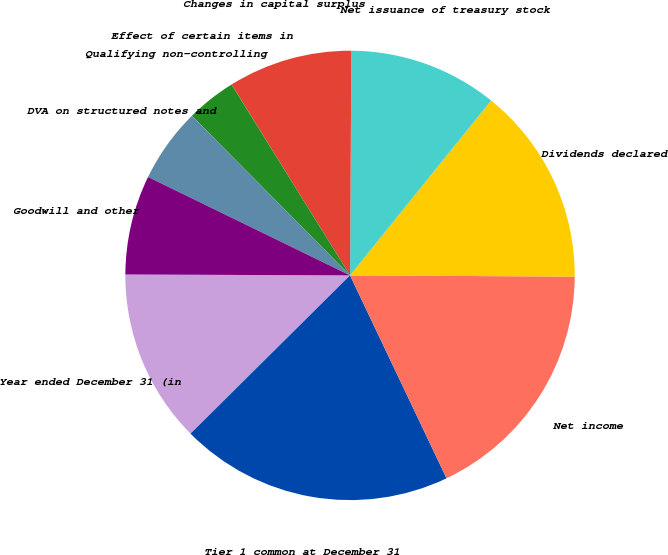Convert chart. <chart><loc_0><loc_0><loc_500><loc_500><pie_chart><fcel>Year ended December 31 (in<fcel>Tier 1 common at December 31<fcel>Net income<fcel>Dividends declared<fcel>Net issuance of treasury stock<fcel>Changes in capital surplus<fcel>Effect of certain items in<fcel>Qualifying non-controlling<fcel>DVA on structured notes and<fcel>Goodwill and other<nl><fcel>12.5%<fcel>19.63%<fcel>17.85%<fcel>14.28%<fcel>10.71%<fcel>8.93%<fcel>0.01%<fcel>3.58%<fcel>5.36%<fcel>7.15%<nl></chart> 